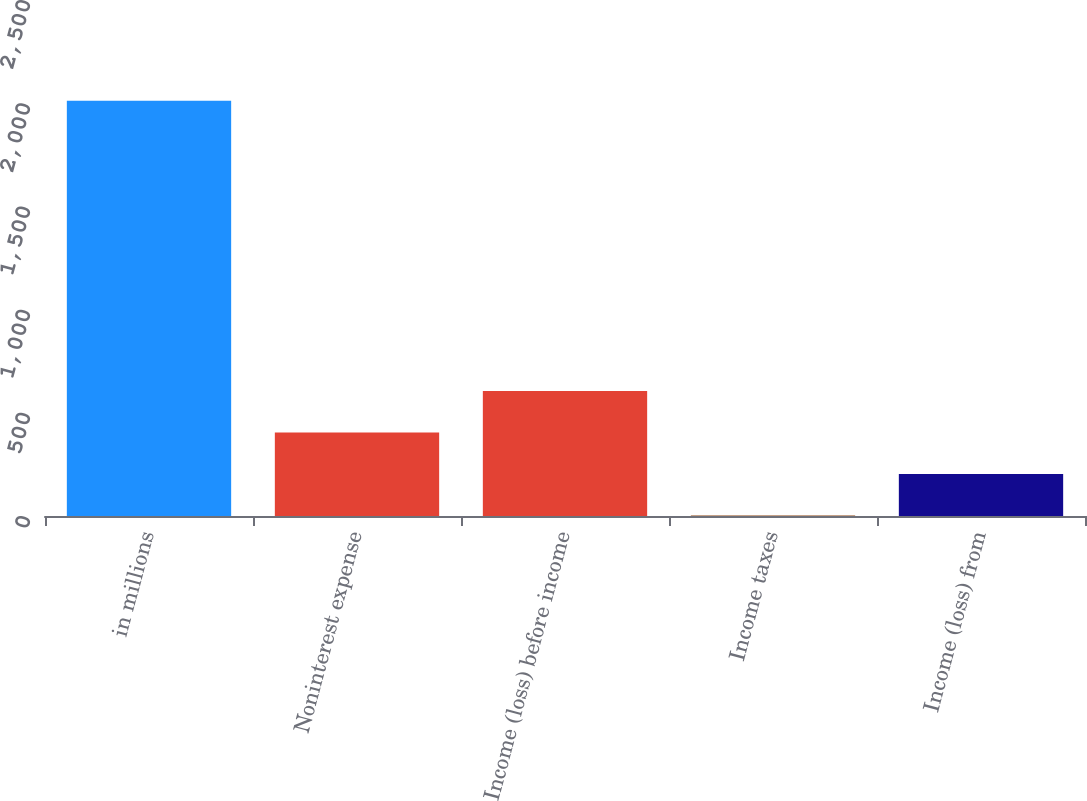<chart> <loc_0><loc_0><loc_500><loc_500><bar_chart><fcel>in millions<fcel>Noninterest expense<fcel>Income (loss) before income<fcel>Income taxes<fcel>Income (loss) from<nl><fcel>2012<fcel>404.8<fcel>605.7<fcel>3<fcel>203.9<nl></chart> 